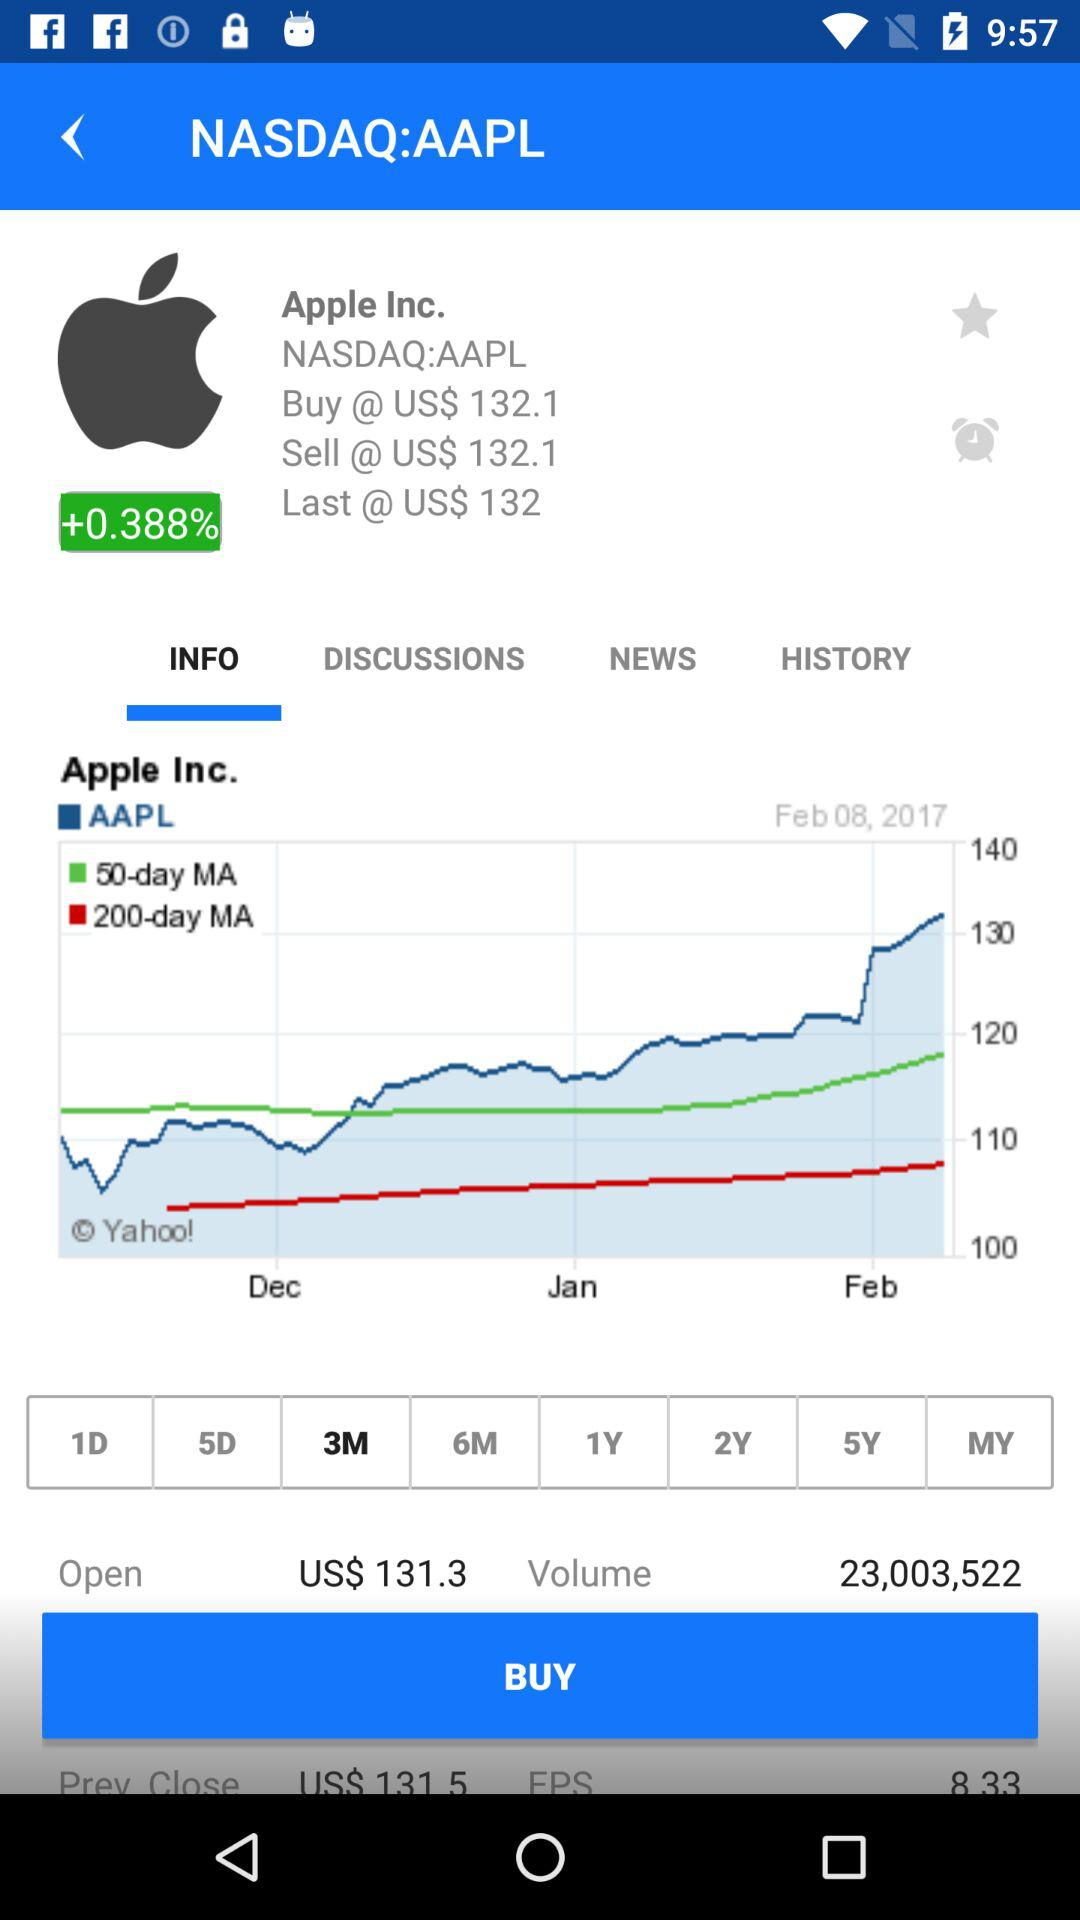Who is the application powered by?
When the provided information is insufficient, respond with <no answer>. <no answer> 